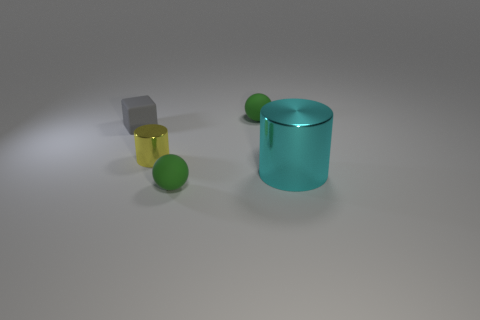Add 2 large metal cylinders. How many objects exist? 7 Subtract all cylinders. How many objects are left? 3 Add 3 large metal objects. How many large metal objects exist? 4 Subtract 0 brown balls. How many objects are left? 5 Subtract all large cylinders. Subtract all tiny yellow cylinders. How many objects are left? 3 Add 4 metallic objects. How many metallic objects are left? 6 